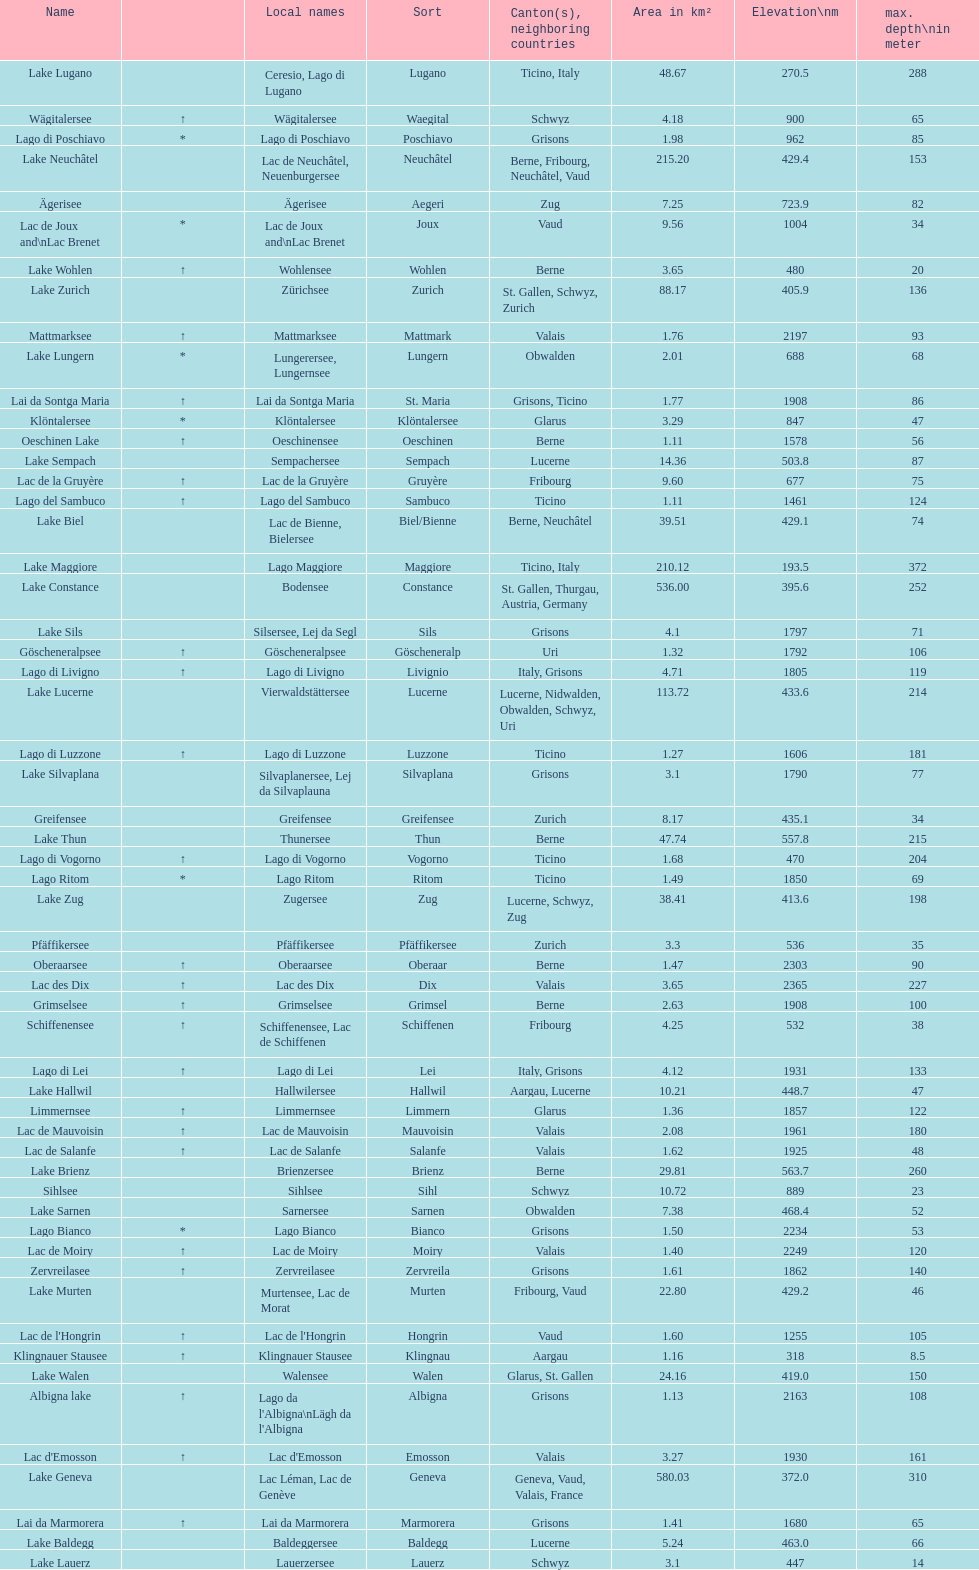What is the total area in km² of lake sils? 4.1. 